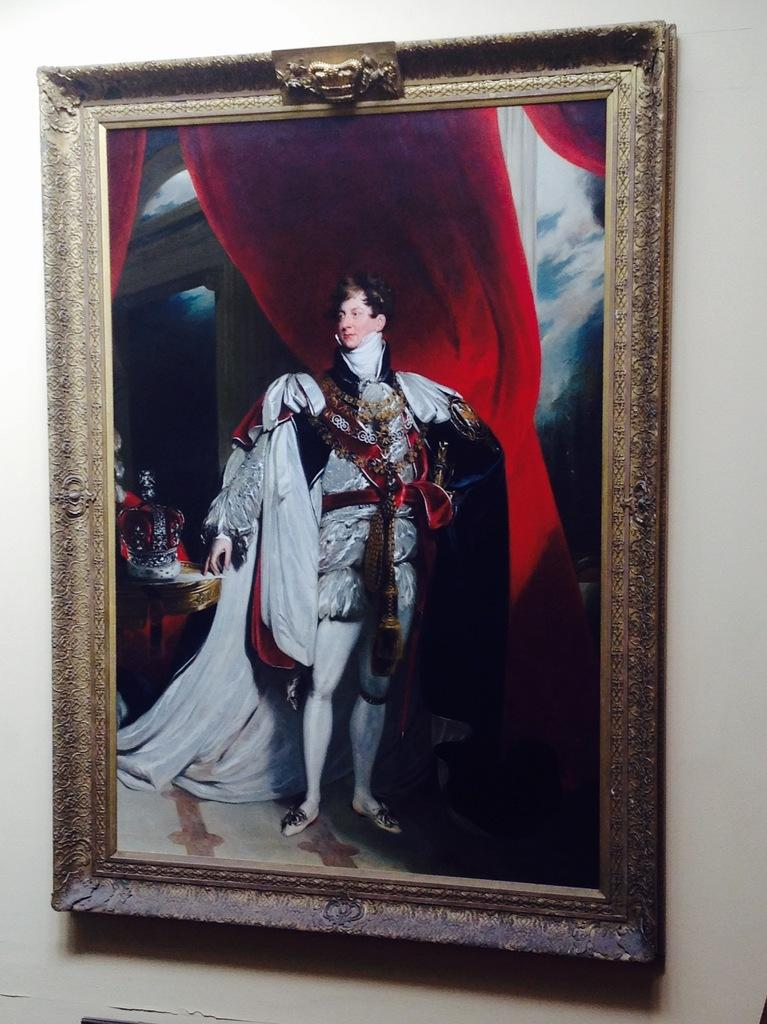What is attached to the wall in the image? There is a photo frame attached to the wall. What is inside the photo frame? The photo frame contains a picture of a person. What is the person in the photo wearing? The person in the photo is wearing a costume. What is the person in the photo doing? The person is standing in the photo. What can be seen behind the person in the photo? There are red color curtains behind the person in the photo. Is there a throne visible in the photo? No, there is no throne visible in the photo; it only shows a person standing in front of red curtains. 